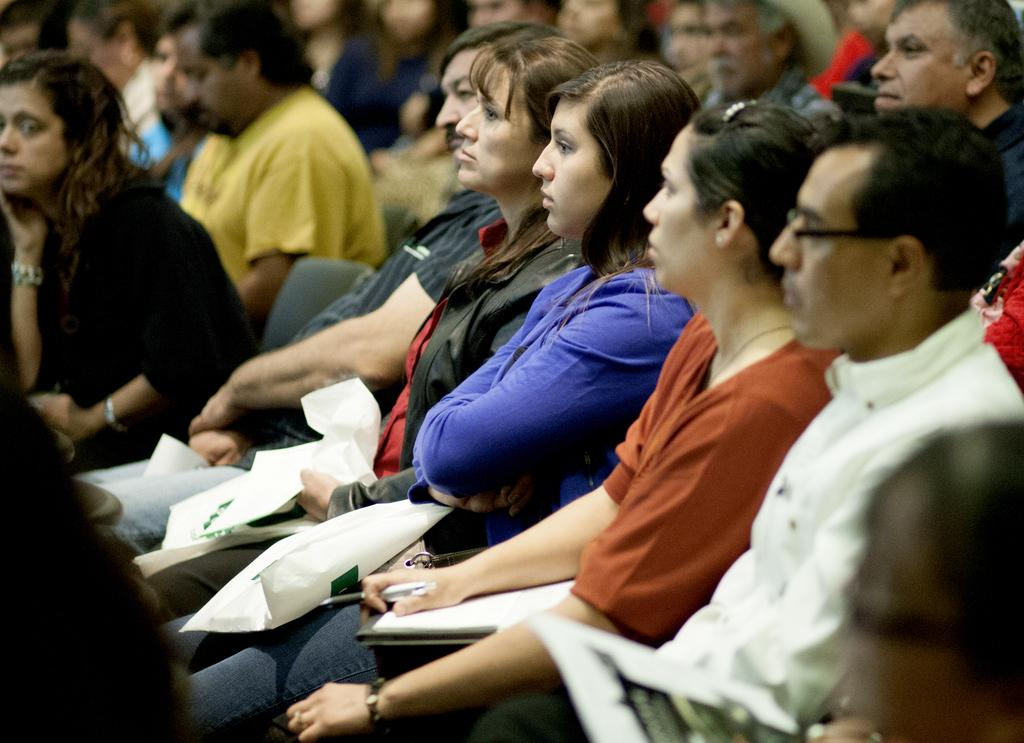What are the people in the image doing? The people in the image are sitting. What are the people holding in their hands? The people are holding something in their hands. What type of government is depicted in the image? There is no reference to a government in the image; it simply shows people sitting and holding something in their hands. 